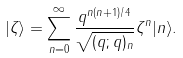Convert formula to latex. <formula><loc_0><loc_0><loc_500><loc_500>| \zeta \rangle = \sum _ { n = 0 } ^ { \infty } \frac { q ^ { n ( n + 1 ) / 4 } } { \sqrt { ( q ; q ) _ { n } } } \zeta ^ { n } | n \rangle .</formula> 